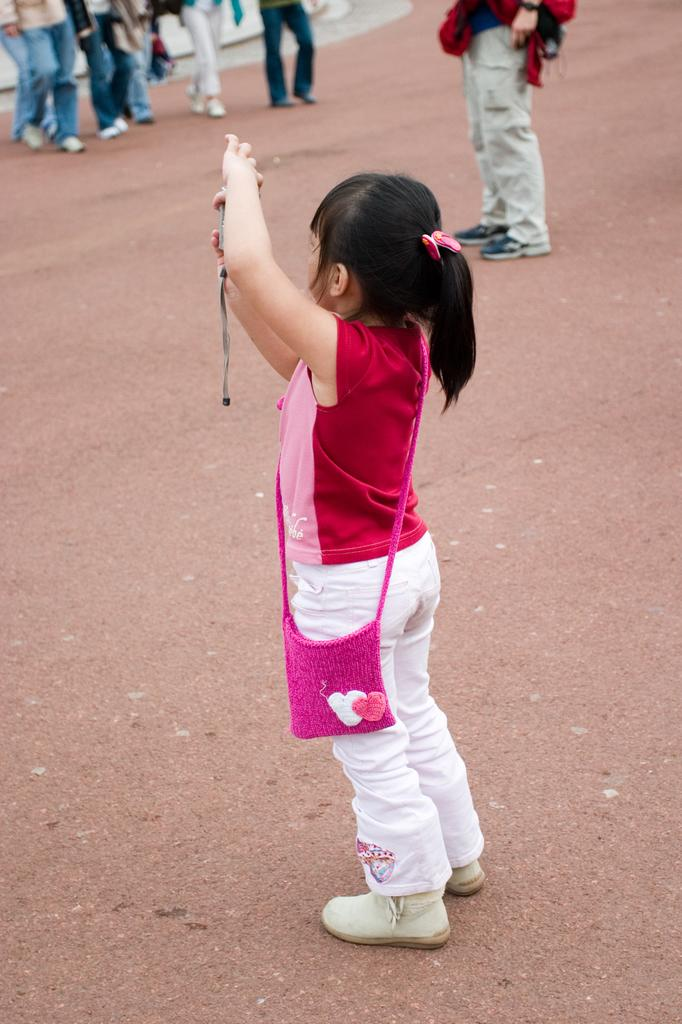Who is the main subject in the image? There is a girl in the image. What is the girl wearing? The girl is wearing a red and pink t-shirt. Where is the girl standing? The girl is standing on a path. What is happening in front of the girl? There are groups of people walking in front of the girl, and there is a person standing in front of her. How many children are holding sticks in the image? There are no children or sticks present in the image. What type of cap is the girl wearing in the image? The girl is not wearing a cap in the image; she is wearing a red and pink t-shirt. 